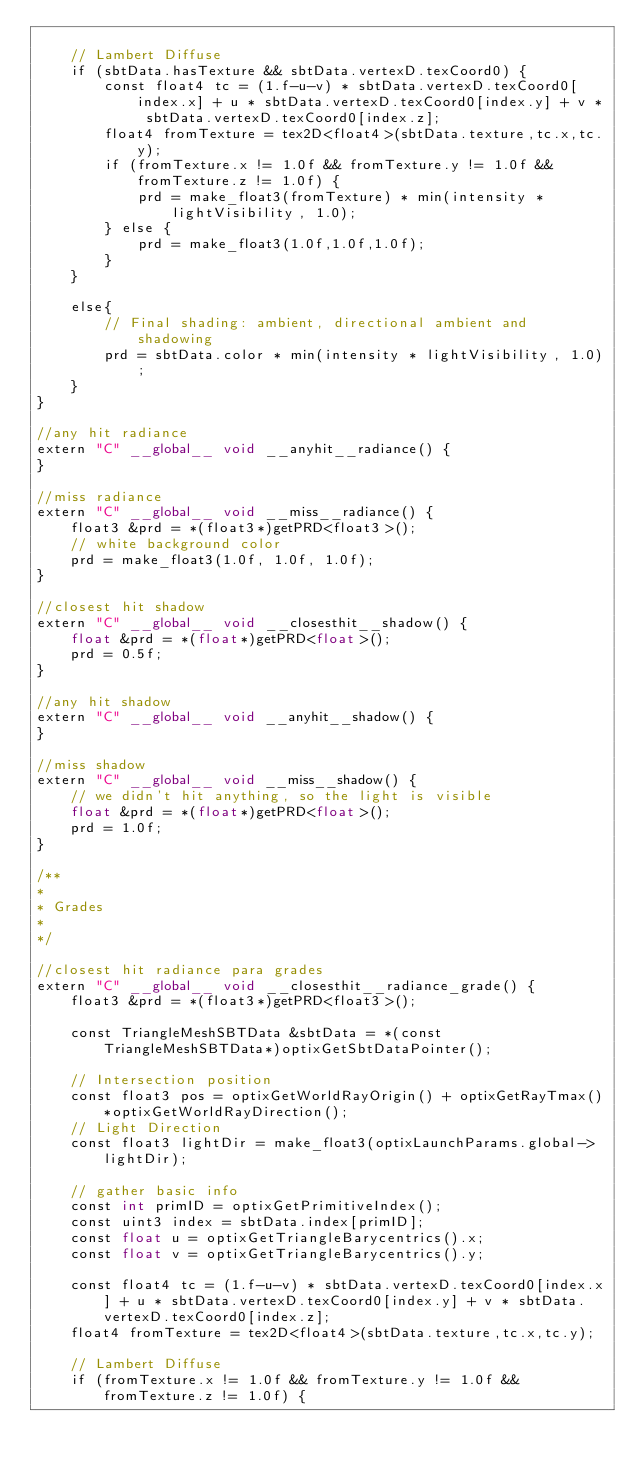<code> <loc_0><loc_0><loc_500><loc_500><_Cuda_>
    // Lambert Diffuse
    if (sbtData.hasTexture && sbtData.vertexD.texCoord0) {
        const float4 tc = (1.f-u-v) * sbtData.vertexD.texCoord0[index.x] + u * sbtData.vertexD.texCoord0[index.y] + v * sbtData.vertexD.texCoord0[index.z];
        float4 fromTexture = tex2D<float4>(sbtData.texture,tc.x,tc.y);
        if (fromTexture.x != 1.0f && fromTexture.y != 1.0f && fromTexture.z != 1.0f) {
            prd = make_float3(fromTexture) * min(intensity * lightVisibility, 1.0);
        } else {
            prd = make_float3(1.0f,1.0f,1.0f);
        }
    }
    
    else{
        // Final shading: ambient, directional ambient and shadowing
        prd = sbtData.color * min(intensity * lightVisibility, 1.0);
    }
}

//any hit radiance
extern "C" __global__ void __anyhit__radiance() {
}

//miss radiance
extern "C" __global__ void __miss__radiance() {
    float3 &prd = *(float3*)getPRD<float3>();
    // white background color
    prd = make_float3(1.0f, 1.0f, 1.0f);    
}

//closest hit shadow
extern "C" __global__ void __closesthit__shadow() {
    float &prd = *(float*)getPRD<float>();
    prd = 0.5f;
}

//any hit shadow
extern "C" __global__ void __anyhit__shadow() {
}

//miss shadow
extern "C" __global__ void __miss__shadow() {
    // we didn't hit anything, so the light is visible
    float &prd = *(float*)getPRD<float>();
    prd = 1.0f;
}

/**
*
* Grades
*
*/

//closest hit radiance para grades
extern "C" __global__ void __closesthit__radiance_grade() {
    float3 &prd = *(float3*)getPRD<float3>();

    const TriangleMeshSBTData &sbtData = *(const TriangleMeshSBTData*)optixGetSbtDataPointer();

    // Intersection position
    const float3 pos = optixGetWorldRayOrigin() + optixGetRayTmax()*optixGetWorldRayDirection();
    // Light Direction
    const float3 lightDir = make_float3(optixLaunchParams.global->lightDir);

    // gather basic info
    const int primID = optixGetPrimitiveIndex();
    const uint3 index = sbtData.index[primID];
    const float u = optixGetTriangleBarycentrics().x;
    const float v = optixGetTriangleBarycentrics().y;

    const float4 tc = (1.f-u-v) * sbtData.vertexD.texCoord0[index.x] + u * sbtData.vertexD.texCoord0[index.y] + v * sbtData.vertexD.texCoord0[index.z];
    float4 fromTexture = tex2D<float4>(sbtData.texture,tc.x,tc.y);

    // Lambert Diffuse
    if (fromTexture.x != 1.0f && fromTexture.y != 1.0f && fromTexture.z != 1.0f) {</code> 